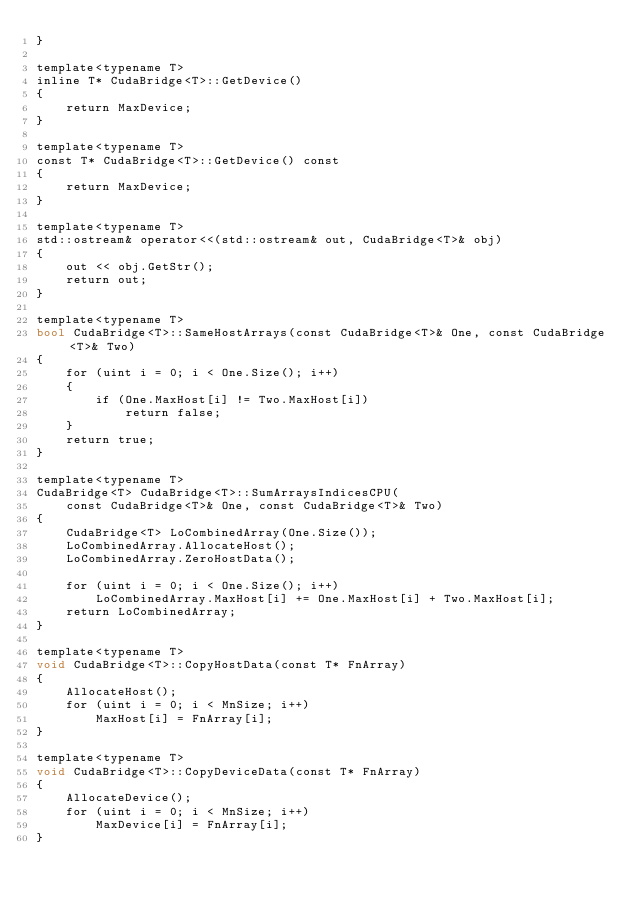<code> <loc_0><loc_0><loc_500><loc_500><_Cuda_>}

template<typename T>
inline T* CudaBridge<T>::GetDevice()
{
    return MaxDevice;
}

template<typename T>
const T* CudaBridge<T>::GetDevice() const
{
    return MaxDevice;
}

template<typename T>
std::ostream& operator<<(std::ostream& out, CudaBridge<T>& obj)
{
    out << obj.GetStr();
    return out;
}

template<typename T>
bool CudaBridge<T>::SameHostArrays(const CudaBridge<T>& One, const CudaBridge<T>& Two)
{
    for (uint i = 0; i < One.Size(); i++)
    {
        if (One.MaxHost[i] != Two.MaxHost[i])
            return false;
    }
    return true;
}

template<typename T>
CudaBridge<T> CudaBridge<T>::SumArraysIndicesCPU(
    const CudaBridge<T>& One, const CudaBridge<T>& Two)
{
    CudaBridge<T> LoCombinedArray(One.Size());
    LoCombinedArray.AllocateHost();
    LoCombinedArray.ZeroHostData();

    for (uint i = 0; i < One.Size(); i++)
        LoCombinedArray.MaxHost[i] += One.MaxHost[i] + Two.MaxHost[i];
    return LoCombinedArray;
}

template<typename T>
void CudaBridge<T>::CopyHostData(const T* FnArray)
{
    AllocateHost();
    for (uint i = 0; i < MnSize; i++)
        MaxHost[i] = FnArray[i];
}

template<typename T>
void CudaBridge<T>::CopyDeviceData(const T* FnArray)
{
    AllocateDevice();
    for (uint i = 0; i < MnSize; i++)
        MaxDevice[i] = FnArray[i];
}</code> 